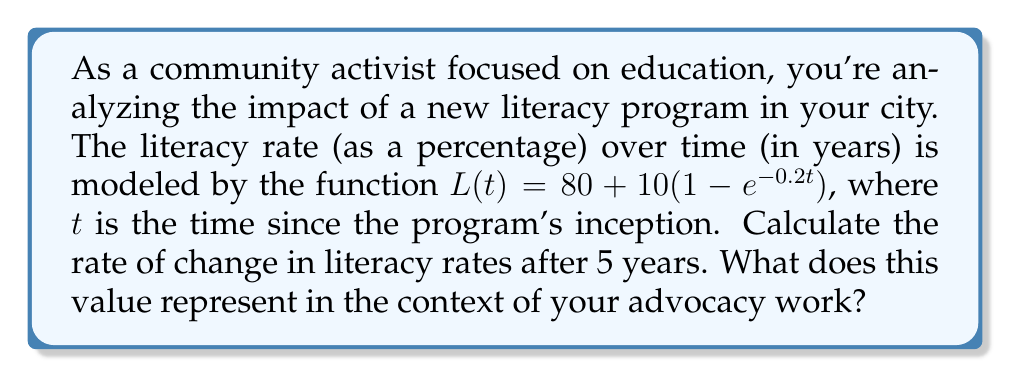Solve this math problem. To solve this problem, we need to find the derivative of the literacy rate function and evaluate it at $t=5$. Here's a step-by-step explanation:

1. The given function for literacy rate is:
   $L(t) = 80 + 10(1 - e^{-0.2t})$

2. To find the rate of change, we need to calculate the derivative $L'(t)$:
   $L'(t) = \frac{d}{dt}[80 + 10(1 - e^{-0.2t})]$

3. The constant 80 disappears when we take the derivative:
   $L'(t) = \frac{d}{dt}[10(1 - e^{-0.2t})]$

4. Using the chain rule:
   $L'(t) = 10 \cdot \frac{d}{dt}[1 - e^{-0.2t}]$
   $L'(t) = 10 \cdot (-1) \cdot (-0.2e^{-0.2t})$

5. Simplify:
   $L'(t) = 2e^{-0.2t}$

6. Now, we evaluate $L'(t)$ at $t=5$:
   $L'(5) = 2e^{-0.2(5)}$
   $L'(5) = 2e^{-1} \approx 0.7358$

This value represents the instantaneous rate of change in literacy rates after 5 years, measured in percentage points per year. In the context of advocacy work, it indicates that the literacy rate is increasing by approximately 0.7358 percentage points per year at the 5-year mark, showing the ongoing positive impact of the literacy program.
Answer: $L'(5) = 2e^{-1} \approx 0.7358$ percentage points per year 